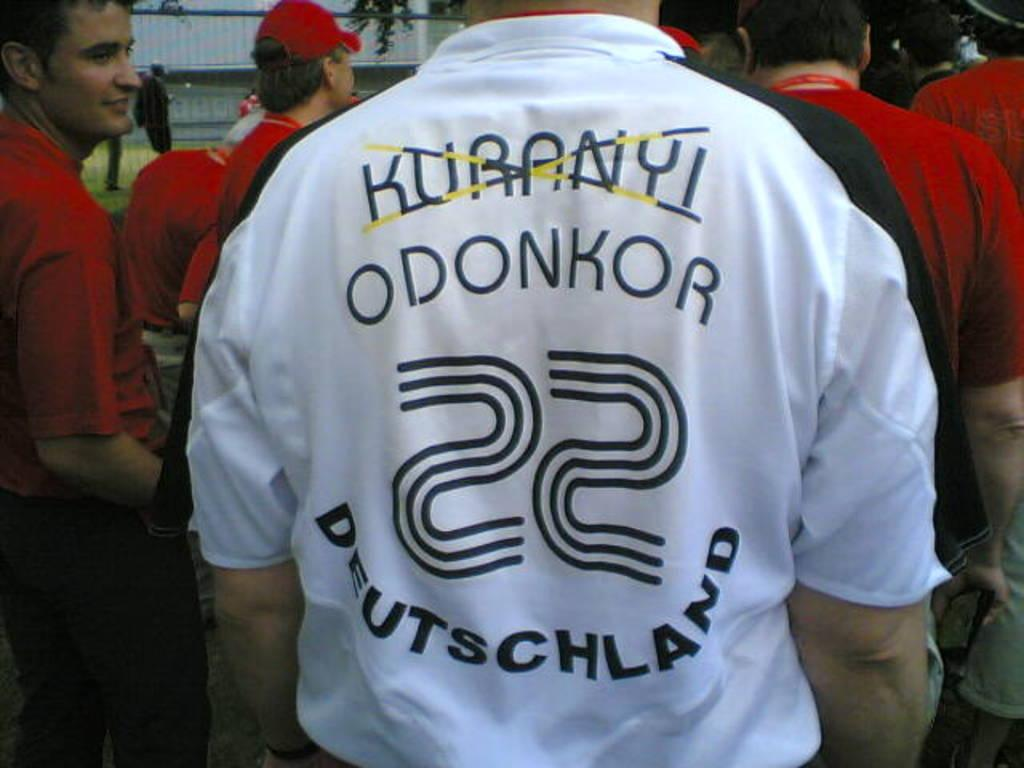<image>
Give a short and clear explanation of the subsequent image. a mans white shirt number 22 from Deutschland is short sleeved 